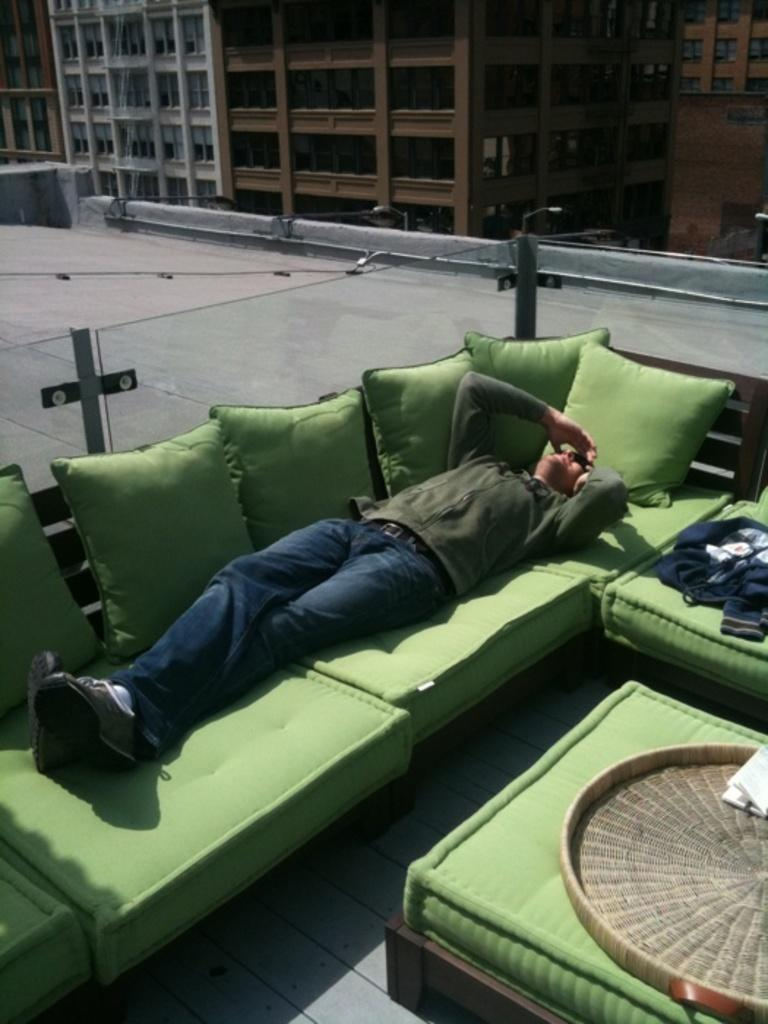What is the main subject of the image? There is a person in the image. What is the person wearing? The person is wearing clothes and footwear. What is the person doing in the image? The person is sleeping on a sofa. What can be seen in the background of the image? There is a building visible at the top of the image. Can you see a robin perched on the mountain in the image? There is no mountain or robin present in the image. 